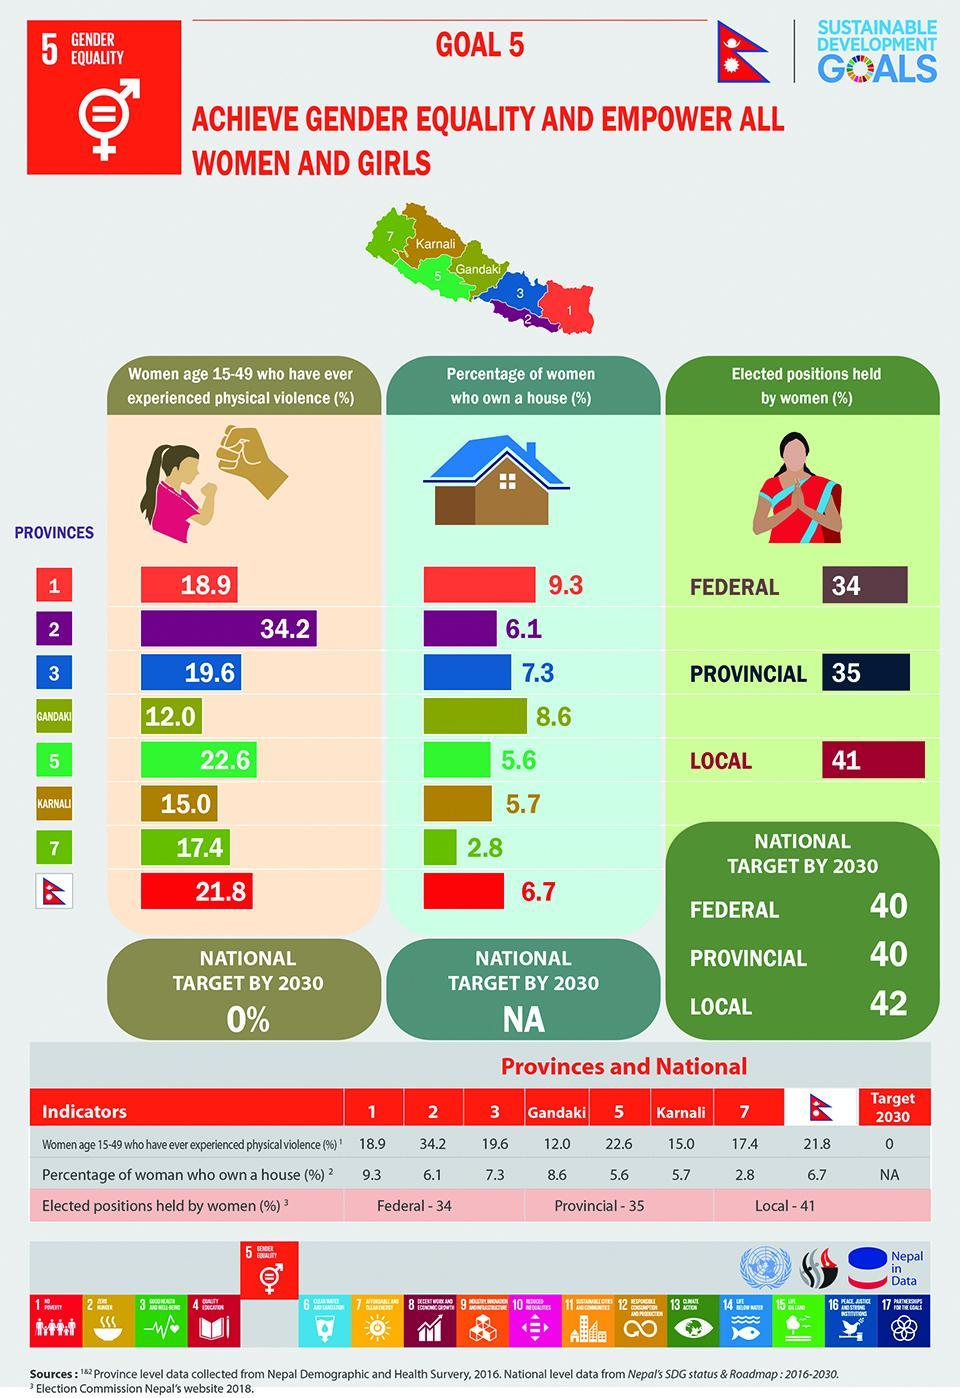What percent of women own a house in the province with the highest rate of physical violence?
Answer the question with a short phrase. 6.1 In which province is the second lowest percentage of women who had experienced physical violence? Karnali In which province is the second highest percentage of women who had experienced physical violence? 5 What percentage of women faced physical violence in the province with lowest house ownership % ? 17.4 Which province has the second highest percentage of women owning a house? Gandaki 